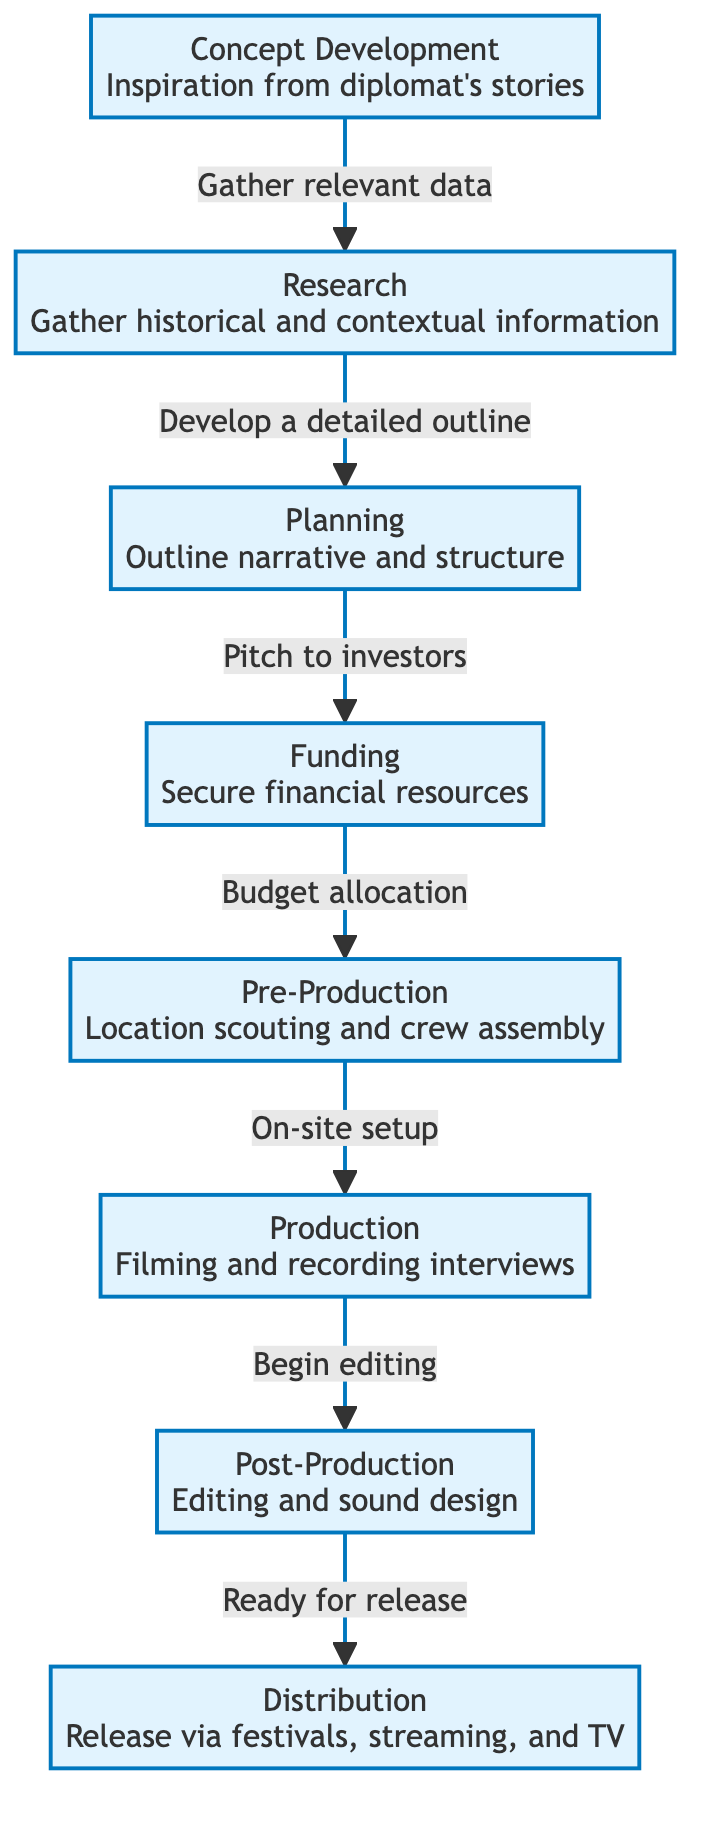What is the first stage in the documentary production workflow? The first stage in the diagram, indicated by the starting node, is "Concept Development".
Answer: Concept Development How many stages are there in total in the workflow? By counting the nodes in the diagram, there are eight distinct stages listed from concept development to distribution.
Answer: 8 What connects the "Pre-Production" and "Production" stages? The arrow from "Pre-Production" to "Production" indicates the connection, with the label "On-site setup".
Answer: On-site setup Which stage involves securing financial resources? The stage for securing financial resources is labeled "Funding".
Answer: Funding What is the last stage in the workflow? The final stage indicated in the flowchart is "Distribution".
Answer: Distribution Explain the relationship between "Planning" and "Funding". "Planning" leads to "Funding" through a labeled connection which is "Pitch to investors", indicating that a detailed outline is necessary to secure funding.
Answer: Pitch to investors Which two stages are connected by a "Begin editing" label? The connection is between "Production" and "Post-Production", linked by the action "Begin editing".
Answer: Production and Post-Production Describe the purpose of the "Research" stage. The "Research" stage is characterized by the action of gathering historical and contextual information to aid the development process.
Answer: Gather historical and contextual information What is the critical output of the "Post-Production" stage? The critical output of this stage is the label "Ready for release", indicating the state of the project before distribution.
Answer: Ready for release 